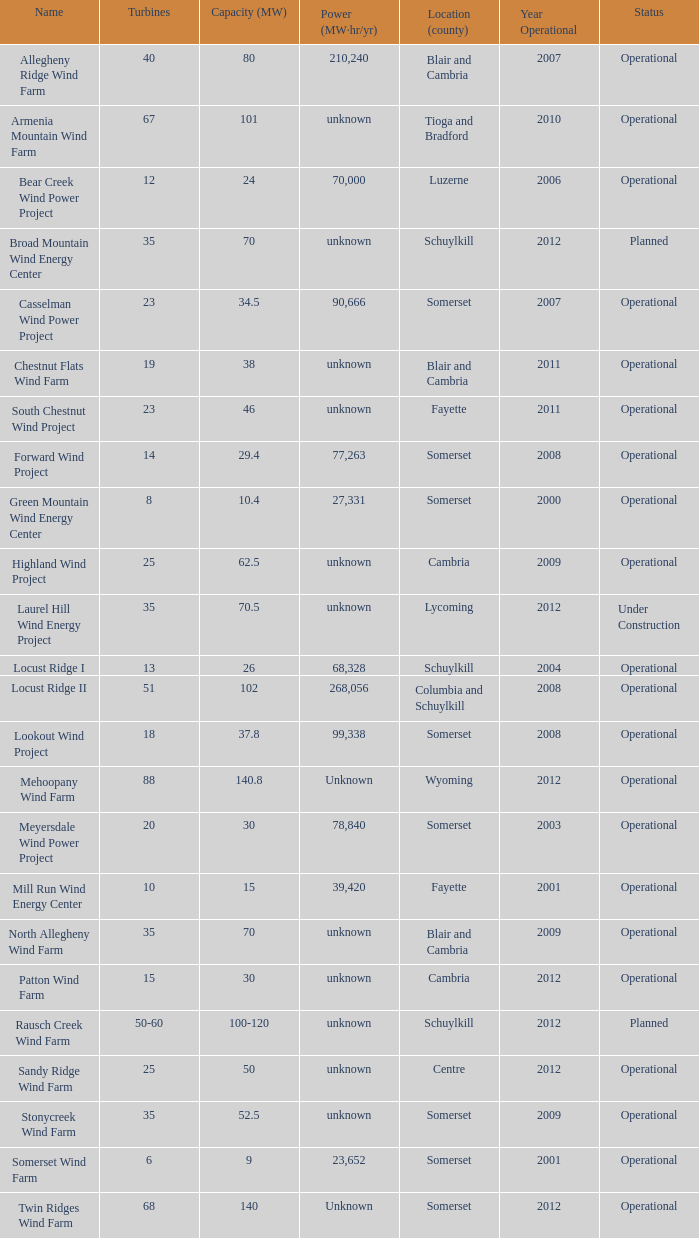What all turbines have a capacity of 30 and have a Somerset location? 20.0. 